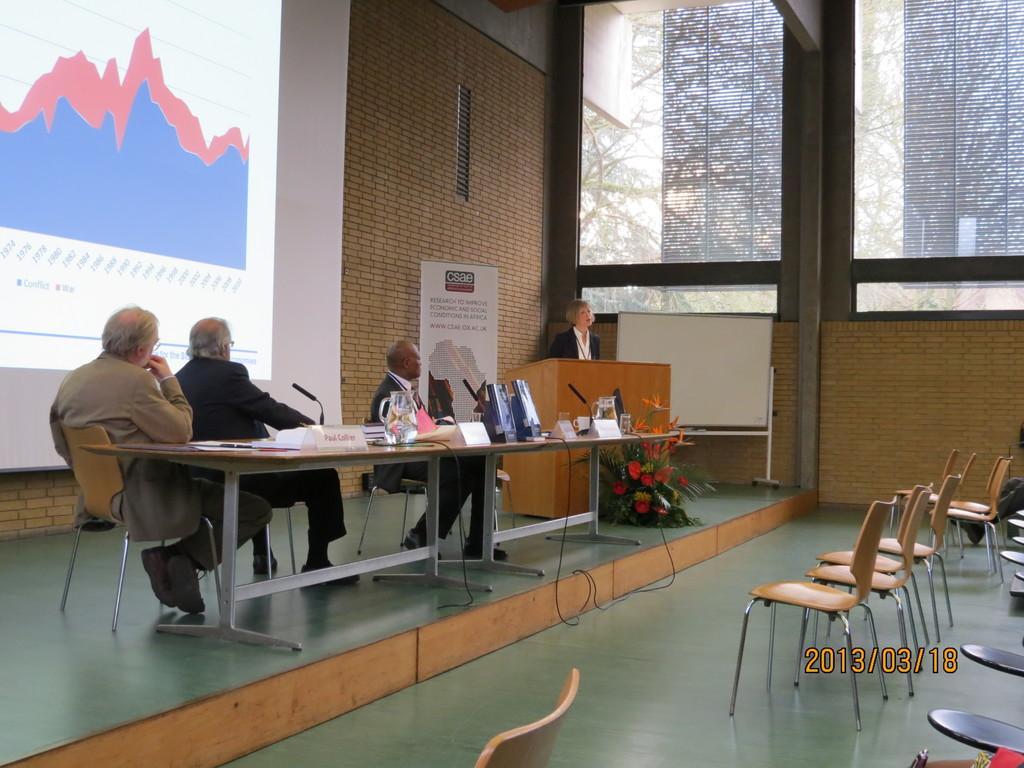Describe this image in one or two sentences. As we can see in the image there is a brick wall, window, screen, few people sitting on chairs and there is a table. On table there are mugs, laptops and posters. 